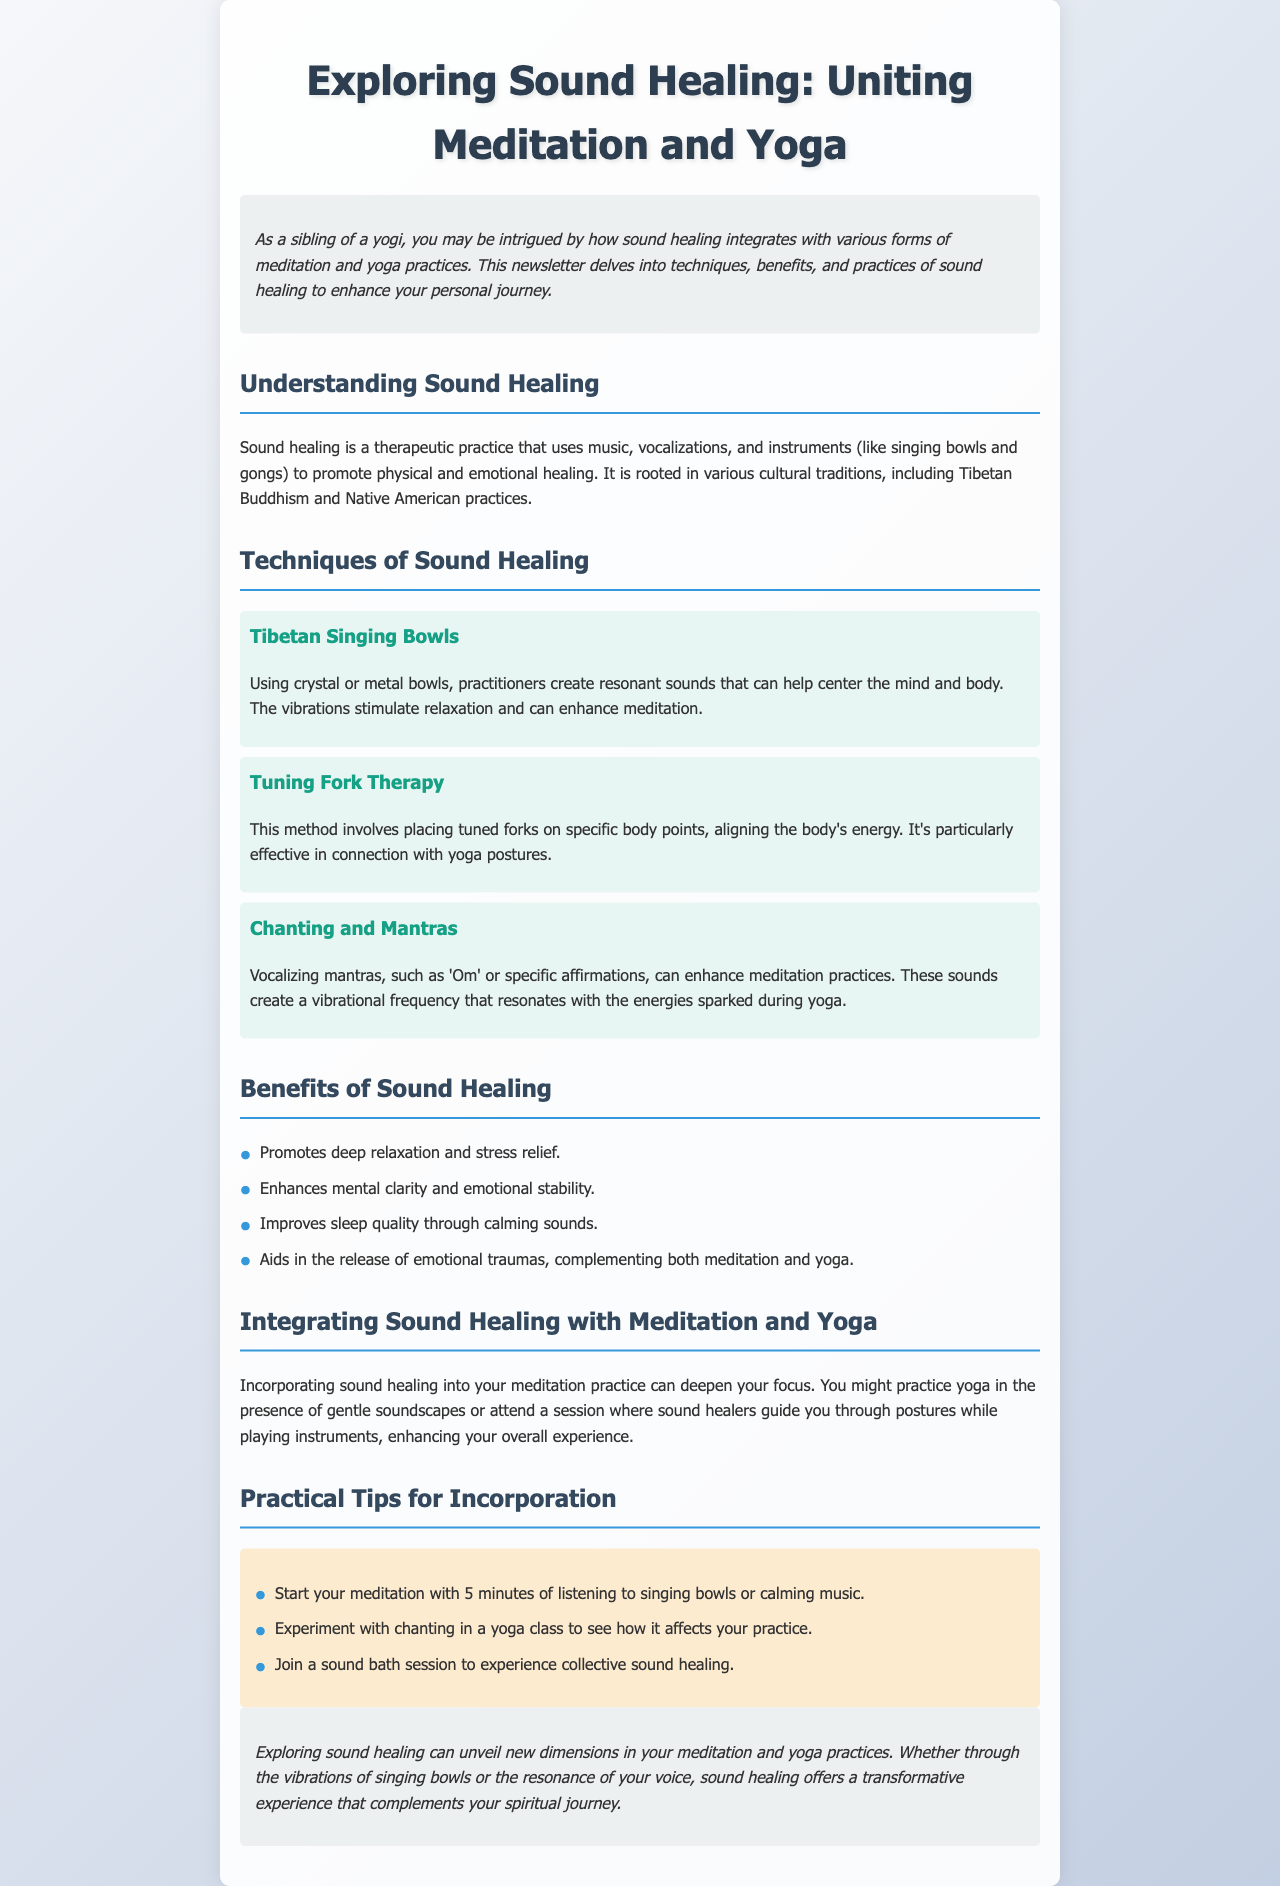What is sound healing? Sound healing is a therapeutic practice that uses music, vocalizations, and instruments to promote physical and emotional healing.
Answer: therapeutic practice What is one technique used in sound healing? The document lists several techniques, one of which is Tibetan Singing Bowls.
Answer: Tibetan Singing Bowls What are the benefits of sound healing? The document lists several benefits, including promoting deep relaxation.
Answer: deep relaxation How can sound healing enhance meditation? Incorporating sound healing into your meditation practice can deepen your focus.
Answer: deepen focus What type of sessions can you join for sound healing? The document mentions joining a sound bath session for collective sound healing.
Answer: sound bath session How long is suggested for listening to singing bowls before meditation? The document recommends starting your meditation with 5 minutes of listening.
Answer: 5 minutes What specific mantra is mentioned in the document? The document mentions the mantra 'Om'.
Answer: Om What is a key characteristic of tuning fork therapy? Tuning fork therapy involves placing tuned forks on specific body points.
Answer: body points 